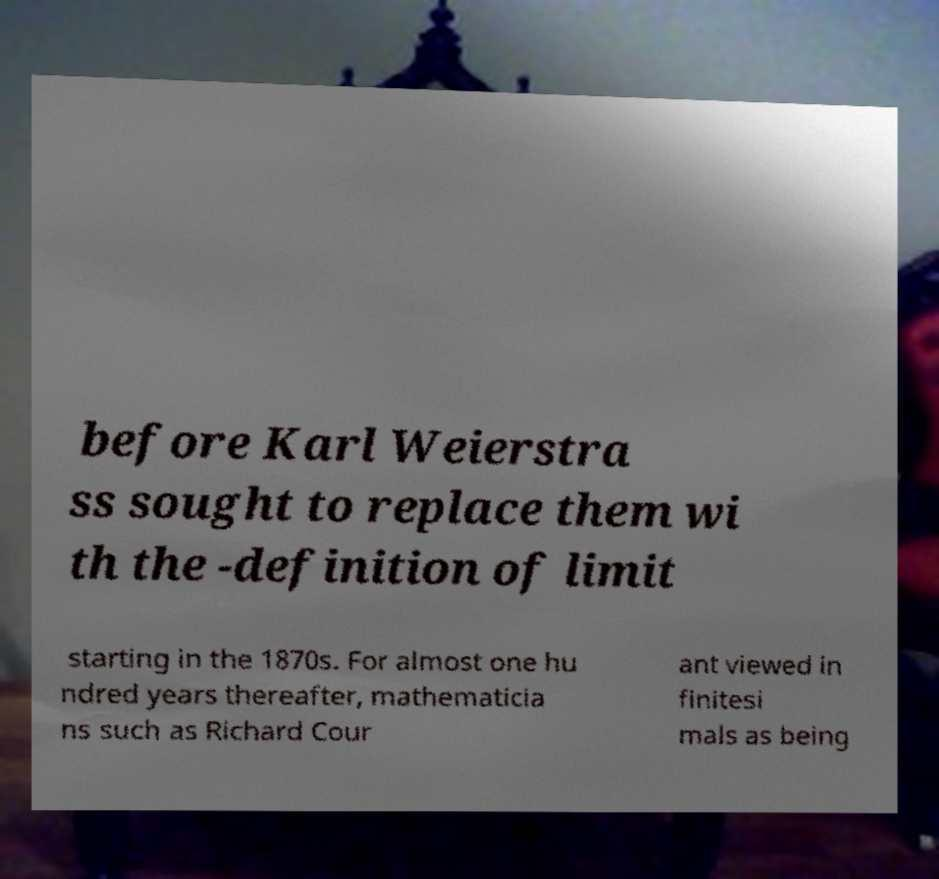I need the written content from this picture converted into text. Can you do that? before Karl Weierstra ss sought to replace them wi th the -definition of limit starting in the 1870s. For almost one hu ndred years thereafter, mathematicia ns such as Richard Cour ant viewed in finitesi mals as being 